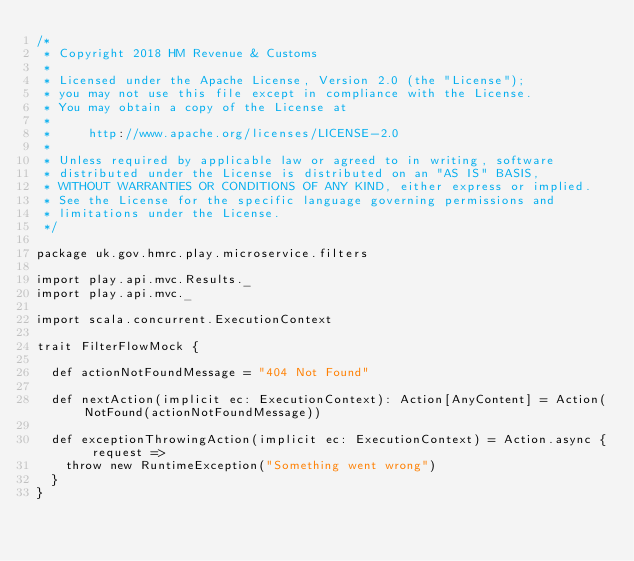<code> <loc_0><loc_0><loc_500><loc_500><_Scala_>/*
 * Copyright 2018 HM Revenue & Customs
 *
 * Licensed under the Apache License, Version 2.0 (the "License");
 * you may not use this file except in compliance with the License.
 * You may obtain a copy of the License at
 *
 *     http://www.apache.org/licenses/LICENSE-2.0
 *
 * Unless required by applicable law or agreed to in writing, software
 * distributed under the License is distributed on an "AS IS" BASIS,
 * WITHOUT WARRANTIES OR CONDITIONS OF ANY KIND, either express or implied.
 * See the License for the specific language governing permissions and
 * limitations under the License.
 */

package uk.gov.hmrc.play.microservice.filters

import play.api.mvc.Results._
import play.api.mvc._

import scala.concurrent.ExecutionContext

trait FilterFlowMock {

  def actionNotFoundMessage = "404 Not Found"

  def nextAction(implicit ec: ExecutionContext): Action[AnyContent] = Action(NotFound(actionNotFoundMessage))

  def exceptionThrowingAction(implicit ec: ExecutionContext) = Action.async { request =>
    throw new RuntimeException("Something went wrong")
  }
}
</code> 